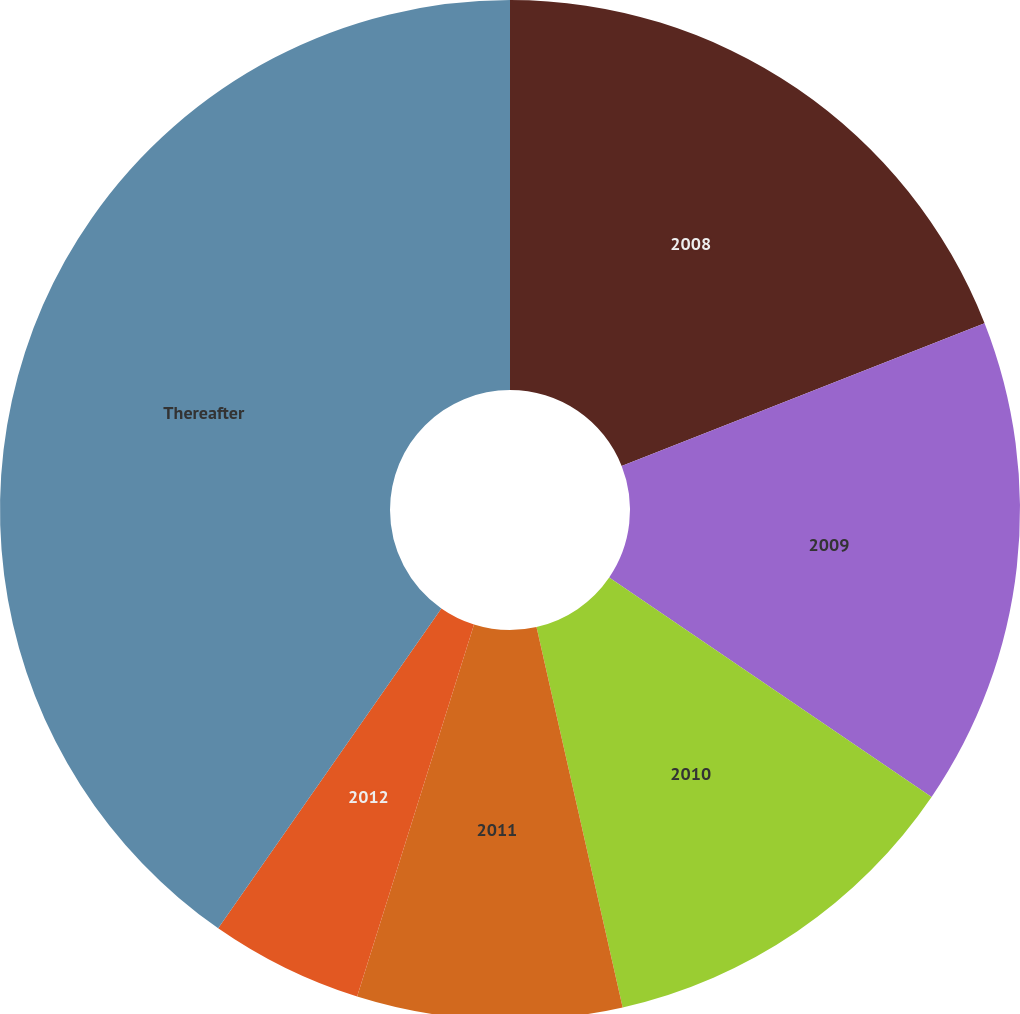<chart> <loc_0><loc_0><loc_500><loc_500><pie_chart><fcel>2008<fcel>2009<fcel>2010<fcel>2011<fcel>2012<fcel>Thereafter<nl><fcel>19.03%<fcel>15.48%<fcel>11.94%<fcel>8.39%<fcel>4.85%<fcel>40.3%<nl></chart> 